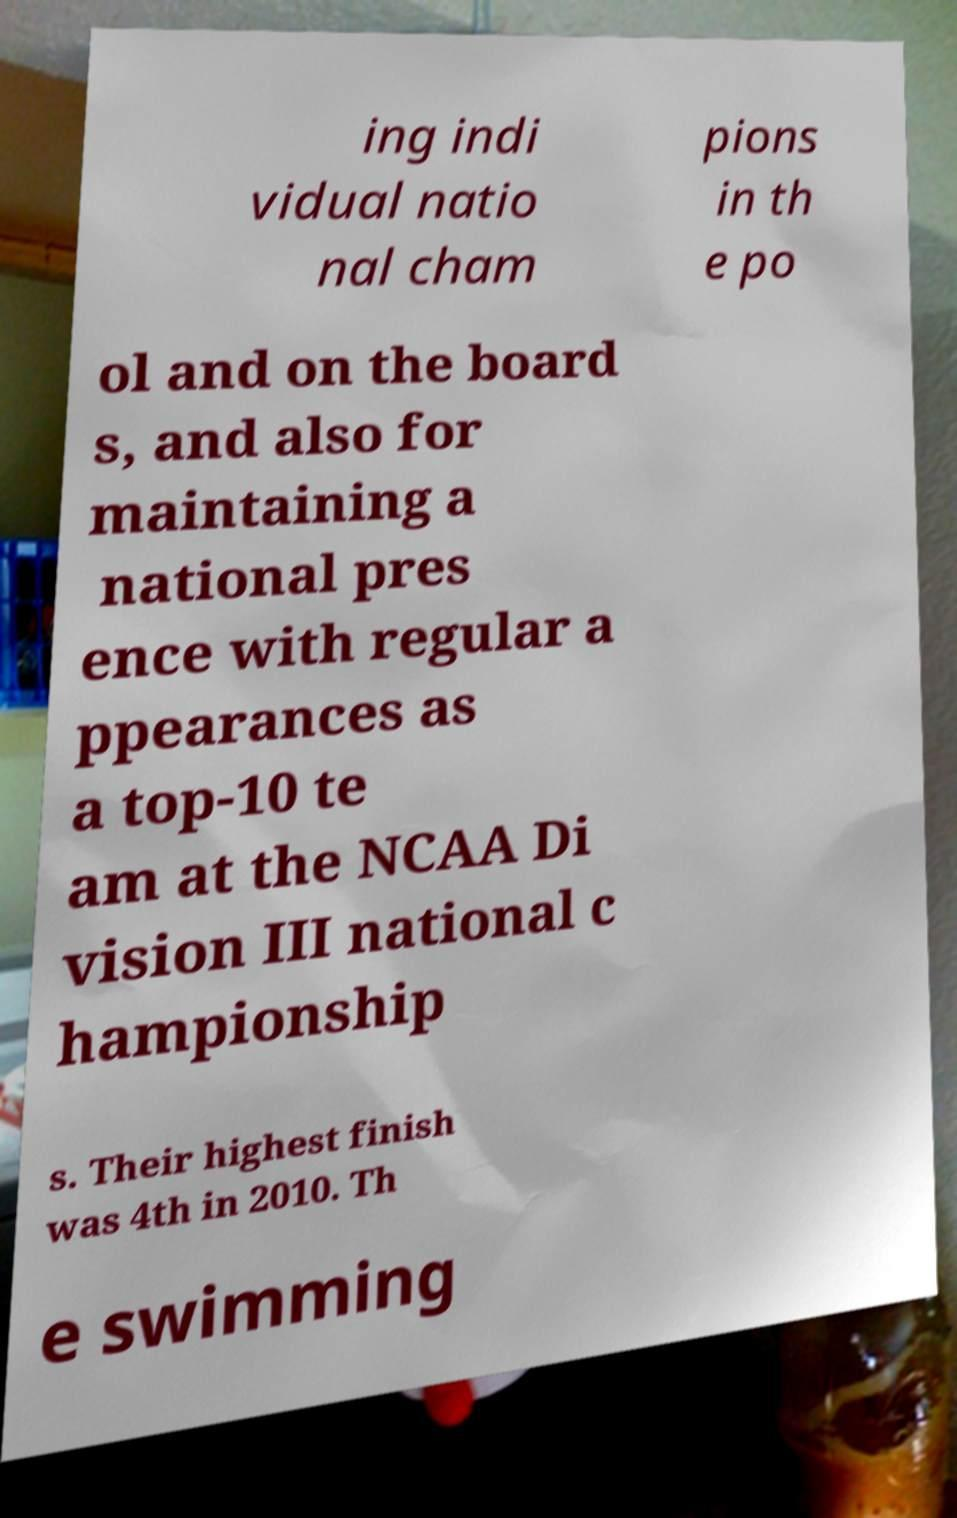For documentation purposes, I need the text within this image transcribed. Could you provide that? ing indi vidual natio nal cham pions in th e po ol and on the board s, and also for maintaining a national pres ence with regular a ppearances as a top-10 te am at the NCAA Di vision III national c hampionship s. Their highest finish was 4th in 2010. Th e swimming 